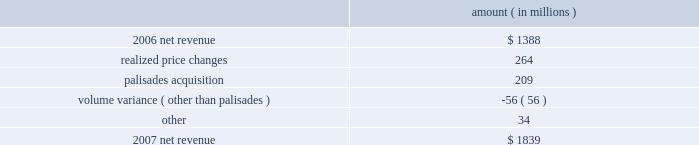Entergy corporation and subsidiaries management's financial discussion and analysis the retail electric price variance resulted from rate increases primarily at entergy louisiana effective september 2006 for the 2005 formula rate plan filing to recover lpsc-approved incremental deferred and ongoing purchased power capacity costs .
The formula rate plan filing is discussed in note 2 to the financial statements .
The volume/weather variance resulted primarily from increased electricity usage in the residential and commercial sectors , including increased usage during the unbilled sales period .
Billed retail electricity usage increased by a total of 1591 gwh , an increase of 1.6% ( 1.6 % ) .
See "critical accounting estimates" herein and note 1 to the financial statements for a discussion of the accounting for unbilled revenues .
The fuel recovery variance is primarily due to the inclusion of grand gulf costs in entergy new orleans' fuel recoveries effective july 1 , 2006 .
In june 2006 , the city council approved the recovery of grand gulf costs through the fuel adjustment clause , without a corresponding change in base rates ( a significant portion of grand gulf costs was previously recovered through base rates ) .
The increase is also due to purchased power costs deferred at entergy louisiana and entergy new orleans as a result of the re-pricing , retroactive to 2003 , of purchased power agreements among entergy system companies as directed by the ferc .
The transmission revenue variance is due to higher rates and the addition of new transmission customers in late-2006 .
The purchased power capacity variance is due to higher capacity charges and new purchased power contracts that began in mid-2006 .
A portion of the variance is due to the amortization of deferred capacity costs and is offset in base revenues due to base rate increases implemented to recover incremental deferred and ongoing purchased power capacity charges at entergy louisiana , as discussed above .
The net wholesale revenue variance is due primarily to 1 ) more energy available for resale at entergy new orleans in 2006 due to the decrease in retail usage caused by customer losses following hurricane katrina and 2 ) the inclusion in 2006 revenue of sales into the wholesale market of entergy new orleans' share of the output of grand gulf , pursuant to city council approval of measures proposed by entergy new orleans to address the reduction in entergy new orleans' retail customer usage caused by hurricane katrina and to provide revenue support for the costs of entergy new orleans' share of grand gulf .
The net wholesale revenue variance is partially offset by the effect of lower wholesale revenues in the third quarter 2006 due to an october 2006 ferc order requiring entergy arkansas to make a refund to a coal plant co-owner resulting from a contract dispute .
Non-utility nuclear following is an analysis of the change in net revenue comparing 2007 to 2006 .
Amount ( in millions ) .
As shown in the table above , net revenue increased for non-utility nuclear by $ 451 million , or 33% ( 33 % ) , for 2007 compared to 2006 primarily due to higher pricing in its contracts to sell power and additional production available resulting from the acquisition of the palisades plant in april 2007 .
Included in the palisades net revenue is $ 50 million of amortization of the palisades purchased power agreement in 2007 , which is non-cash revenue and is discussed in note 15 to the financial statements .
The increase was partially offset by the effect on revenues of four .
Based on the analysis of the change in net revenue what was the percent of the annual change in net revenue sourced from realized price changes? 
Computations: (264 / 451)
Answer: 0.58537. 